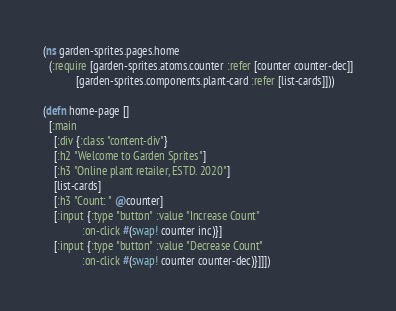<code> <loc_0><loc_0><loc_500><loc_500><_Clojure_>(ns garden-sprites.pages.home
  (:require [garden-sprites.atoms.counter :refer [counter counter-dec]]
            [garden-sprites.components.plant-card :refer [list-cards]]))

(defn home-page []
  [:main
    [:div {:class "content-div"}
    [:h2 "Welcome to Garden Sprites"]
    [:h3 "Online plant retailer, ESTD. 2020"]
    [list-cards]
    [:h3 "Count: " @counter]
    [:input {:type "button" :value "Increase Count"
              :on-click #(swap! counter inc)}]
    [:input {:type "button" :value "Decrease Count"
              :on-click #(swap! counter counter-dec)}]]])</code> 